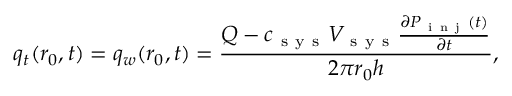<formula> <loc_0><loc_0><loc_500><loc_500>q _ { t } ( r _ { 0 } , t ) = q _ { w } ( r _ { 0 } , t ) = \frac { Q - c _ { s y s } V _ { s y s } \frac { \partial P _ { i n j } ( t ) } { \partial t } } { 2 \pi r _ { 0 } h } ,</formula> 